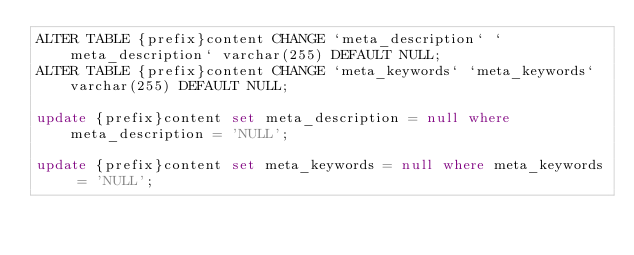Convert code to text. <code><loc_0><loc_0><loc_500><loc_500><_SQL_>ALTER TABLE {prefix}content CHANGE `meta_description` `meta_description` varchar(255) DEFAULT NULL;
ALTER TABLE {prefix}content CHANGE `meta_keywords` `meta_keywords` varchar(255) DEFAULT NULL;

update {prefix}content set meta_description = null where meta_description = 'NULL';

update {prefix}content set meta_keywords = null where meta_keywords = 'NULL';</code> 